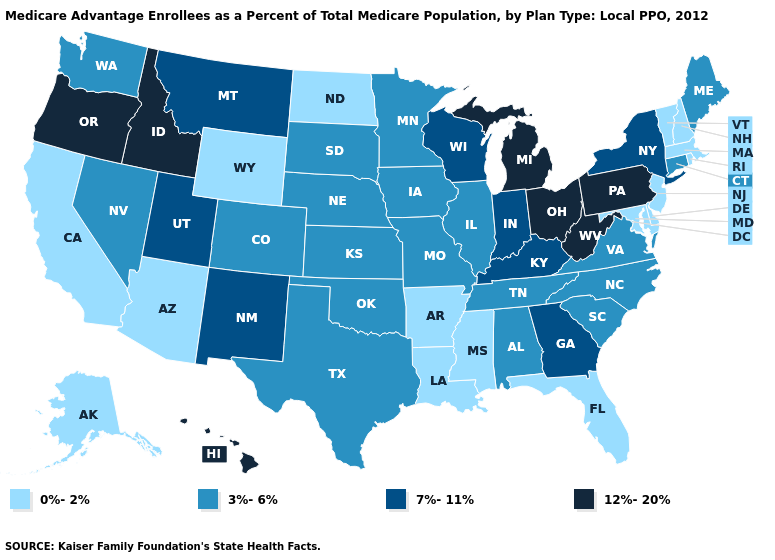Name the states that have a value in the range 0%-2%?
Quick response, please. Alaska, Arkansas, Arizona, California, Delaware, Florida, Louisiana, Massachusetts, Maryland, Mississippi, North Dakota, New Hampshire, New Jersey, Rhode Island, Vermont, Wyoming. What is the value of Oregon?
Give a very brief answer. 12%-20%. Does the map have missing data?
Be succinct. No. Which states have the lowest value in the USA?
Keep it brief. Alaska, Arkansas, Arizona, California, Delaware, Florida, Louisiana, Massachusetts, Maryland, Mississippi, North Dakota, New Hampshire, New Jersey, Rhode Island, Vermont, Wyoming. What is the highest value in the West ?
Concise answer only. 12%-20%. Does Wyoming have the same value as Rhode Island?
Short answer required. Yes. What is the highest value in the South ?
Write a very short answer. 12%-20%. How many symbols are there in the legend?
Concise answer only. 4. Among the states that border Maine , which have the lowest value?
Short answer required. New Hampshire. Does New Jersey have a lower value than Rhode Island?
Concise answer only. No. Does North Carolina have a higher value than North Dakota?
Concise answer only. Yes. Which states hav the highest value in the Northeast?
Keep it brief. Pennsylvania. Does Washington have the same value as Louisiana?
Give a very brief answer. No. Name the states that have a value in the range 3%-6%?
Write a very short answer. Alabama, Colorado, Connecticut, Iowa, Illinois, Kansas, Maine, Minnesota, Missouri, North Carolina, Nebraska, Nevada, Oklahoma, South Carolina, South Dakota, Tennessee, Texas, Virginia, Washington. Does Illinois have the highest value in the USA?
Short answer required. No. 